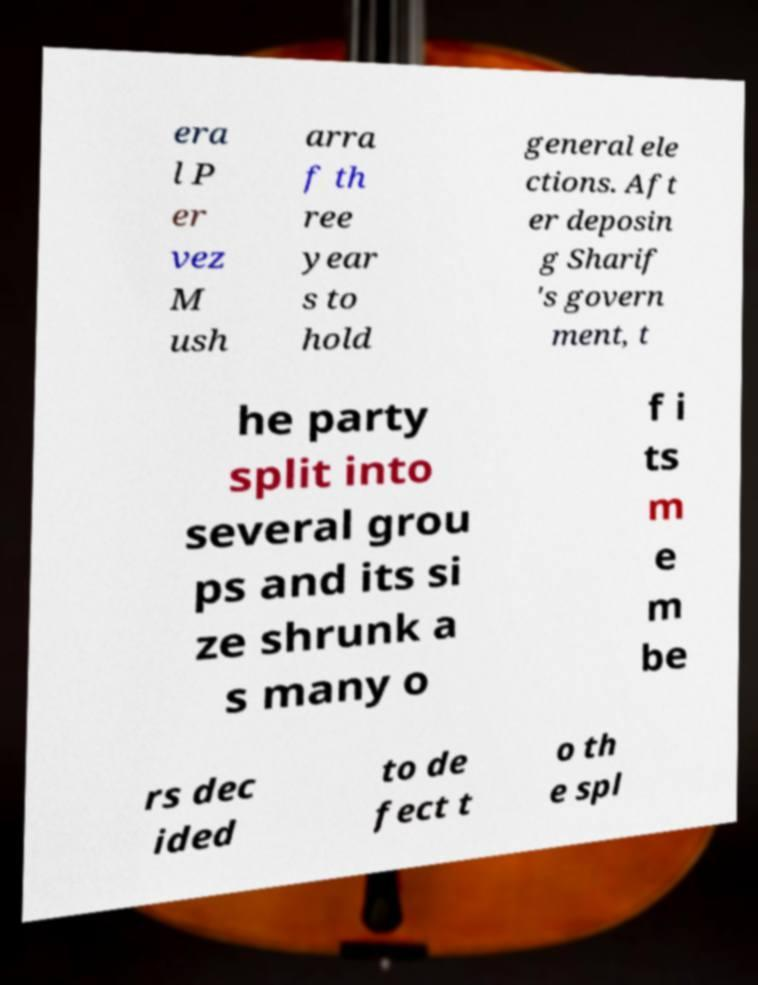Can you accurately transcribe the text from the provided image for me? era l P er vez M ush arra f th ree year s to hold general ele ctions. Aft er deposin g Sharif 's govern ment, t he party split into several grou ps and its si ze shrunk a s many o f i ts m e m be rs dec ided to de fect t o th e spl 